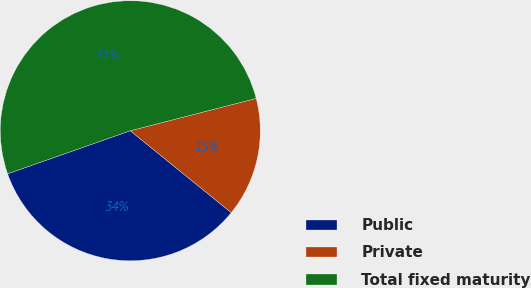<chart> <loc_0><loc_0><loc_500><loc_500><pie_chart><fcel>Public<fcel>Private<fcel>Total fixed maturity<nl><fcel>33.78%<fcel>14.85%<fcel>51.37%<nl></chart> 